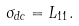Convert formula to latex. <formula><loc_0><loc_0><loc_500><loc_500>\sigma _ { d c } = L _ { 1 1 } .</formula> 